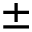<formula> <loc_0><loc_0><loc_500><loc_500>\pm</formula> 